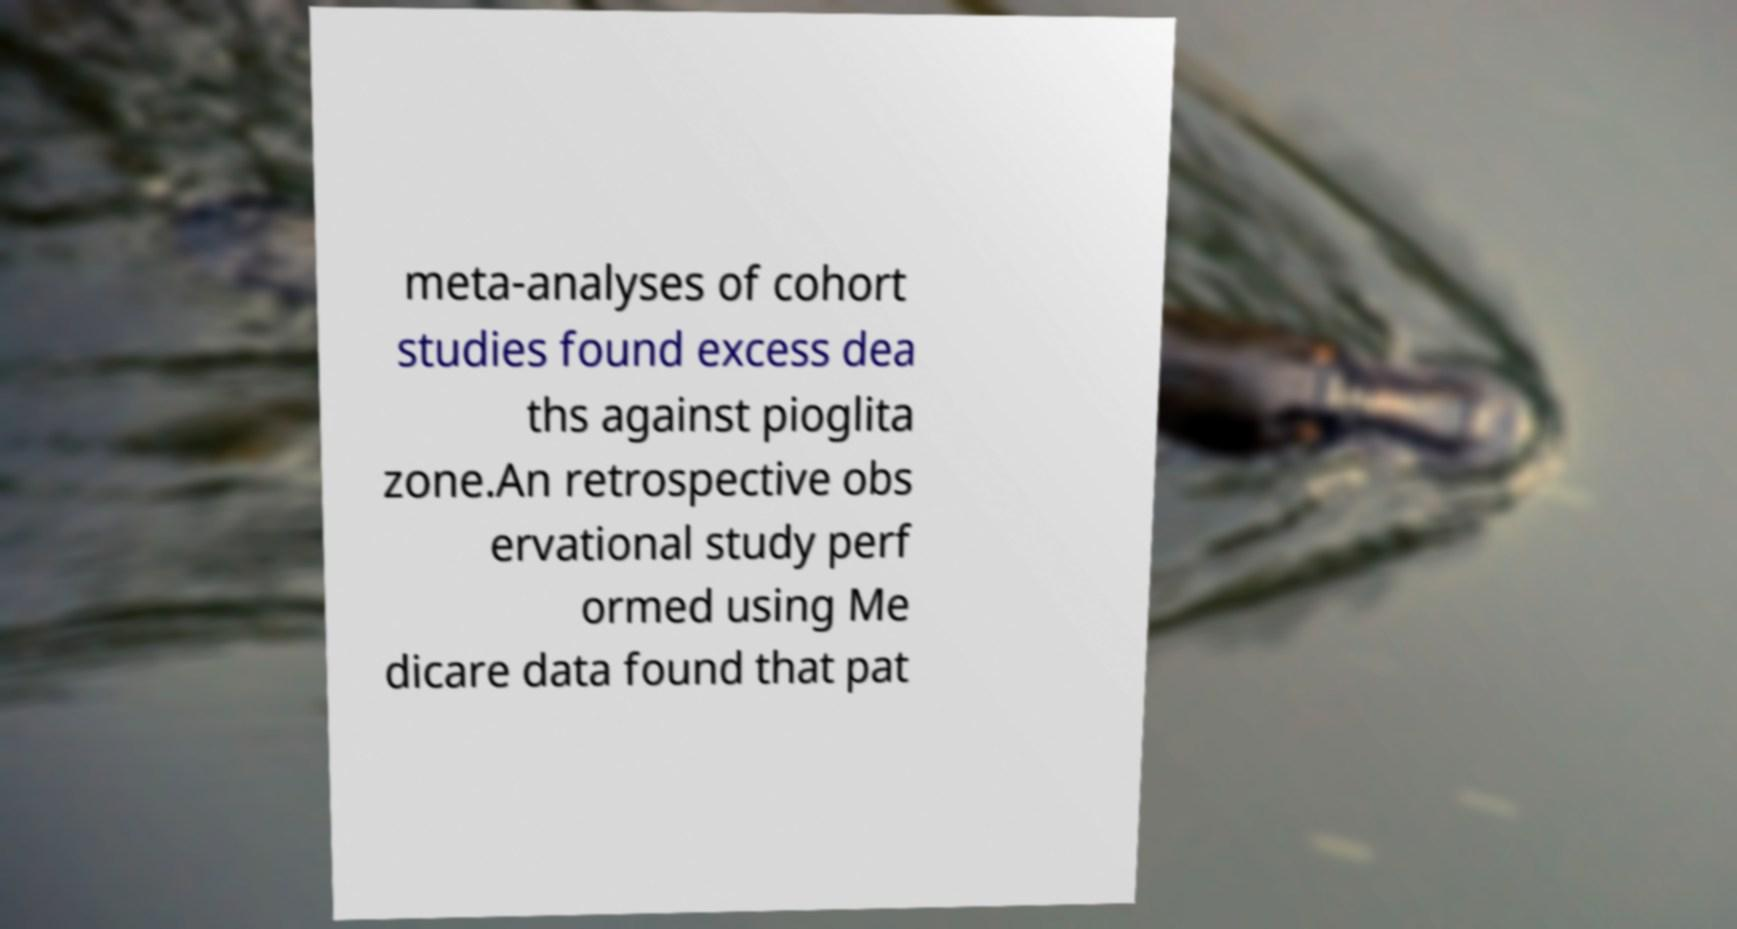Could you assist in decoding the text presented in this image and type it out clearly? meta-analyses of cohort studies found excess dea ths against pioglita zone.An retrospective obs ervational study perf ormed using Me dicare data found that pat 